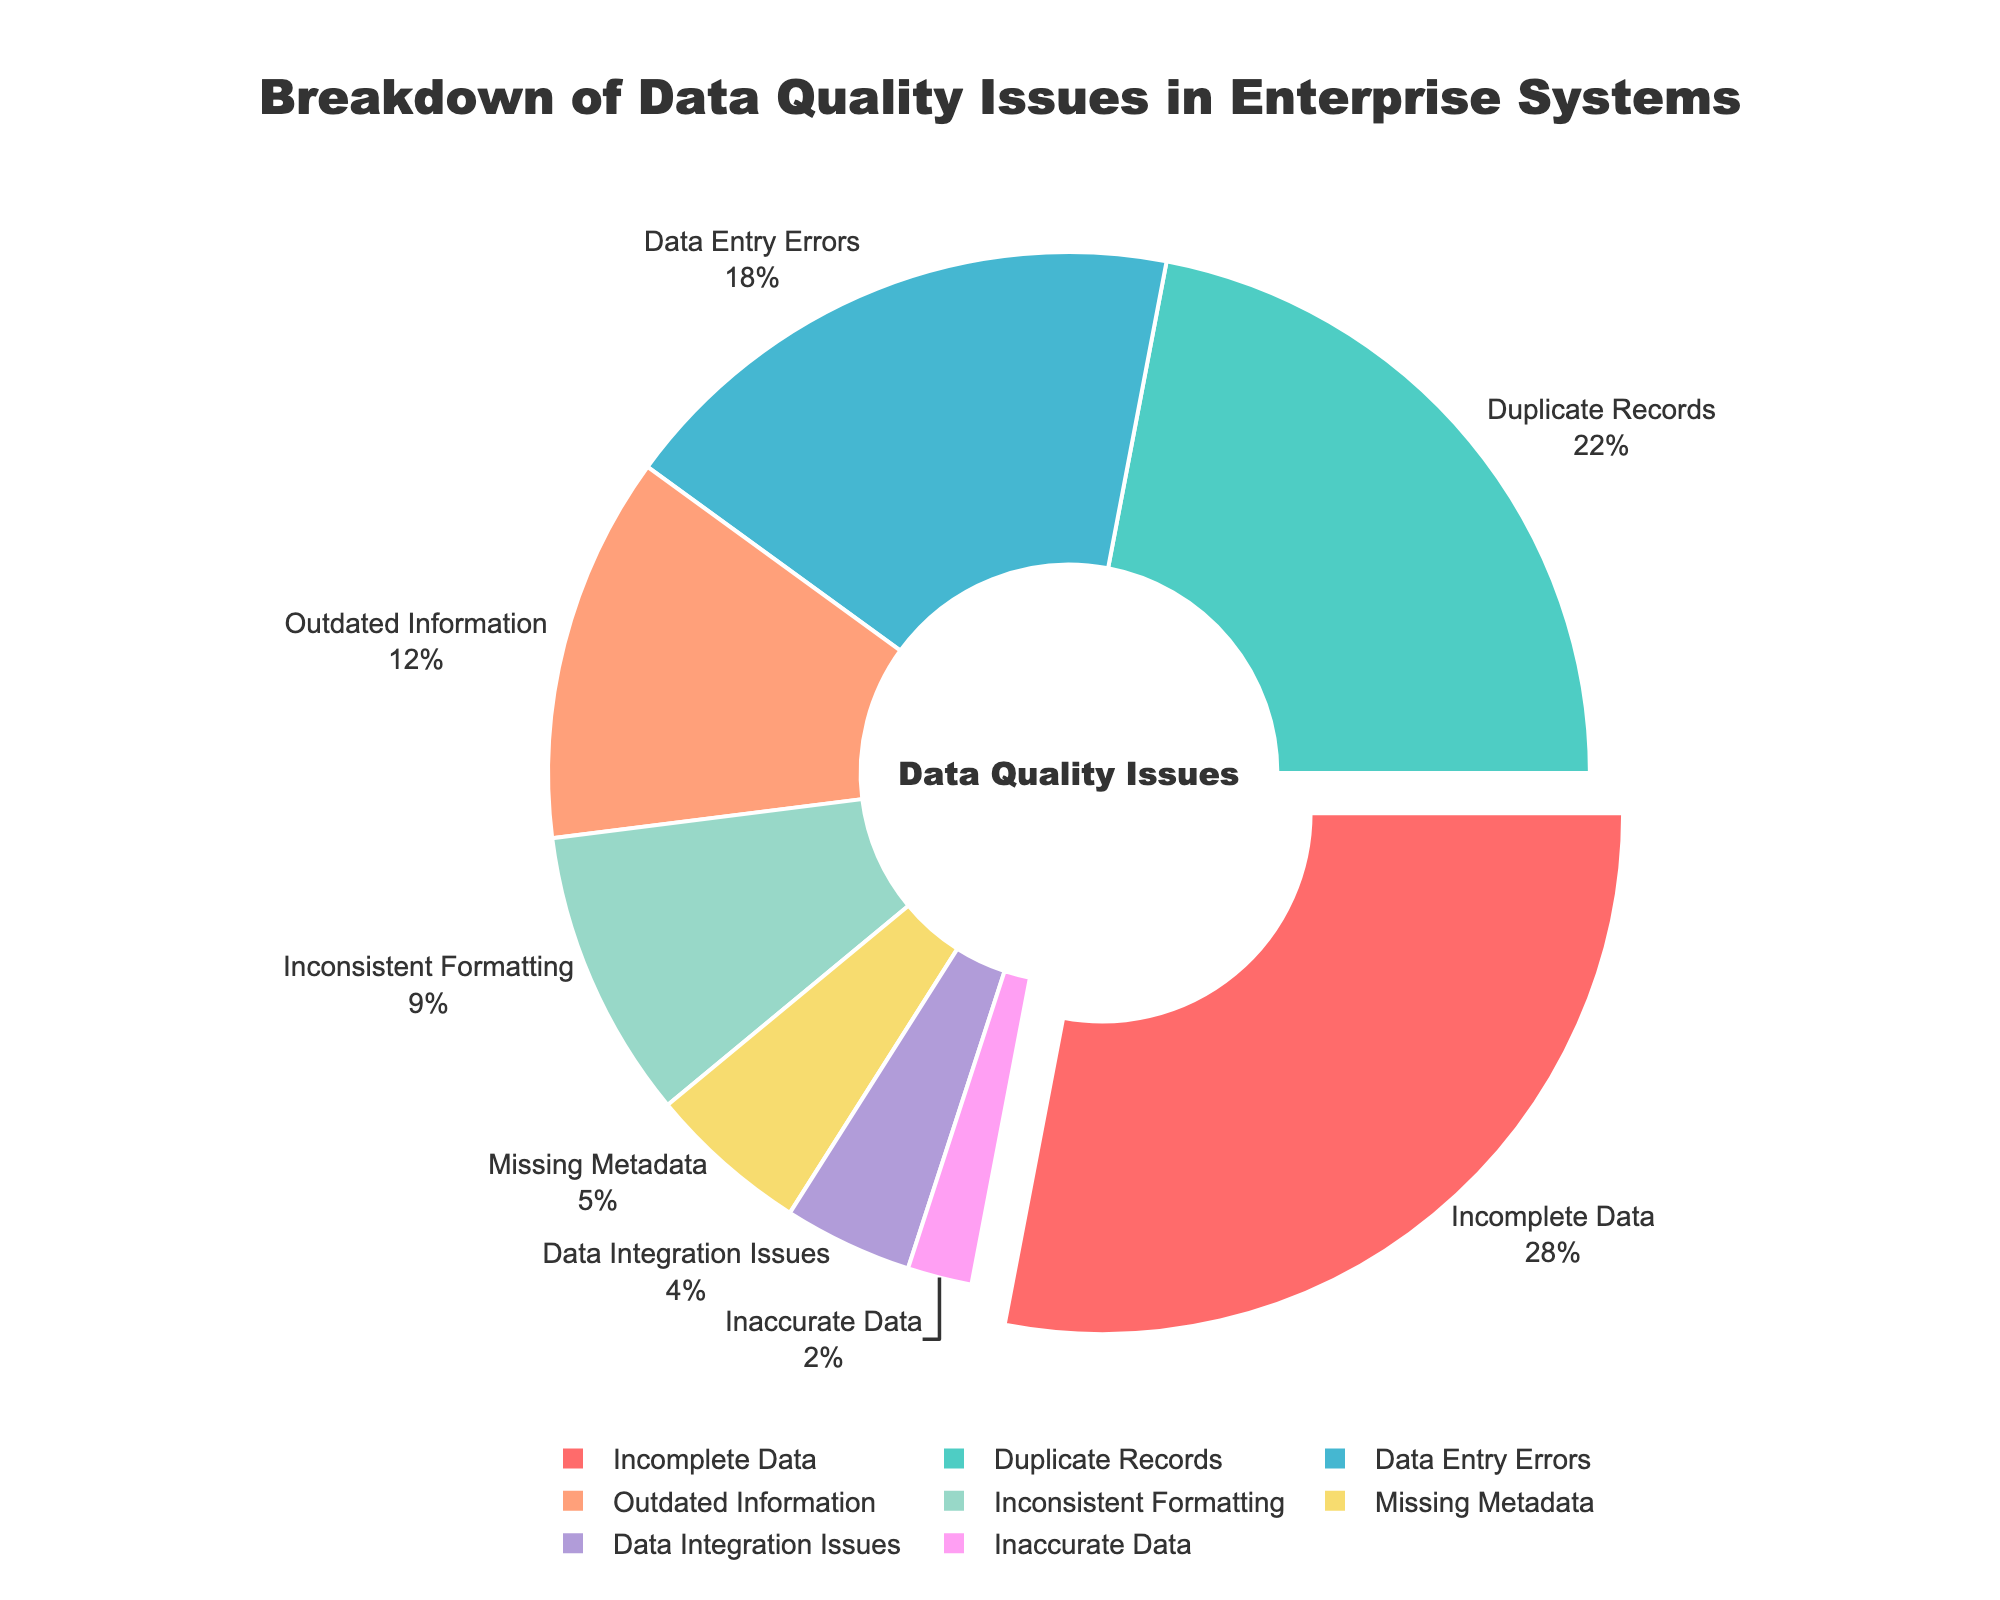What percentage of data quality issues are caused by incomplete data? To find the percentage related to incomplete data, refer to the segment labeled "Incomplete Data" in the pie chart. The percentage is listed next to the label.
Answer: 28% How much higher is the percentage of data entry errors compared to inaccurate data? Locate the percentages for both "Data Entry Errors" (18%) and "Inaccurate Data" (2%) in the chart. Subtract the smaller percentage from the larger one: 18% - 2% = 16%.
Answer: 16% Which type of data quality issue has the smallest percentage? Identify the segment with the smallest percentage in the chart. The label next to the smallest segment is "Inaccurate Data" at 2%.
Answer: Inaccurate Data What is the combined percentage for outdated information and missing metadata? Find the percentages for both "Outdated Information" (12%) and "Missing Metadata" (5%). Add them together: 12% + 5% = 17%.
Answer: 17% Which data quality issue type has the second highest percentage and what is it? Compare the percentages in the chart and identify the one with the second highest value. The segment for "Duplicate Records" is second highest at 22%.
Answer: Duplicate Records, 22% Is the percentage of inconsistent formatting greater than data integration issues? Locate the percentages for "Inconsistent Formatting" (9%) and "Data Integration Issues" (4%) in the chart. Compare the two values: 9% > 4%
Answer: Yes How much more does incomplete data account for compared to missing metadata? Refer to the percentages for "Incomplete Data" (28%) and "Missing Metadata" (5%). Subtract the smaller percentage from the larger one: 28% - 5% = 23%.
Answer: 23% What is the percentage difference between the largest and smallest data quality issues? Identify the largest (Incomplete Data, 28%) and smallest (Inaccurate Data, 2%) percentages in the chart. Subtract the smaller from the larger: 28% - 2% = 26%.
Answer: 26% Which type of data quality issue is represented by the yellow color? Find the yellow segment in the pie chart and look at the label next to it. The label for the yellow segment is "Outdated Information".
Answer: Outdated Information How does the percentage of duplicate records compare to that of data entry errors? Compare the percentages of "Duplicate Records" (22%) and "Data Entry Errors" (18%) in the chart. The percentage for duplicate records is higher than that for data entry errors.
Answer: Duplicate Records is higher 